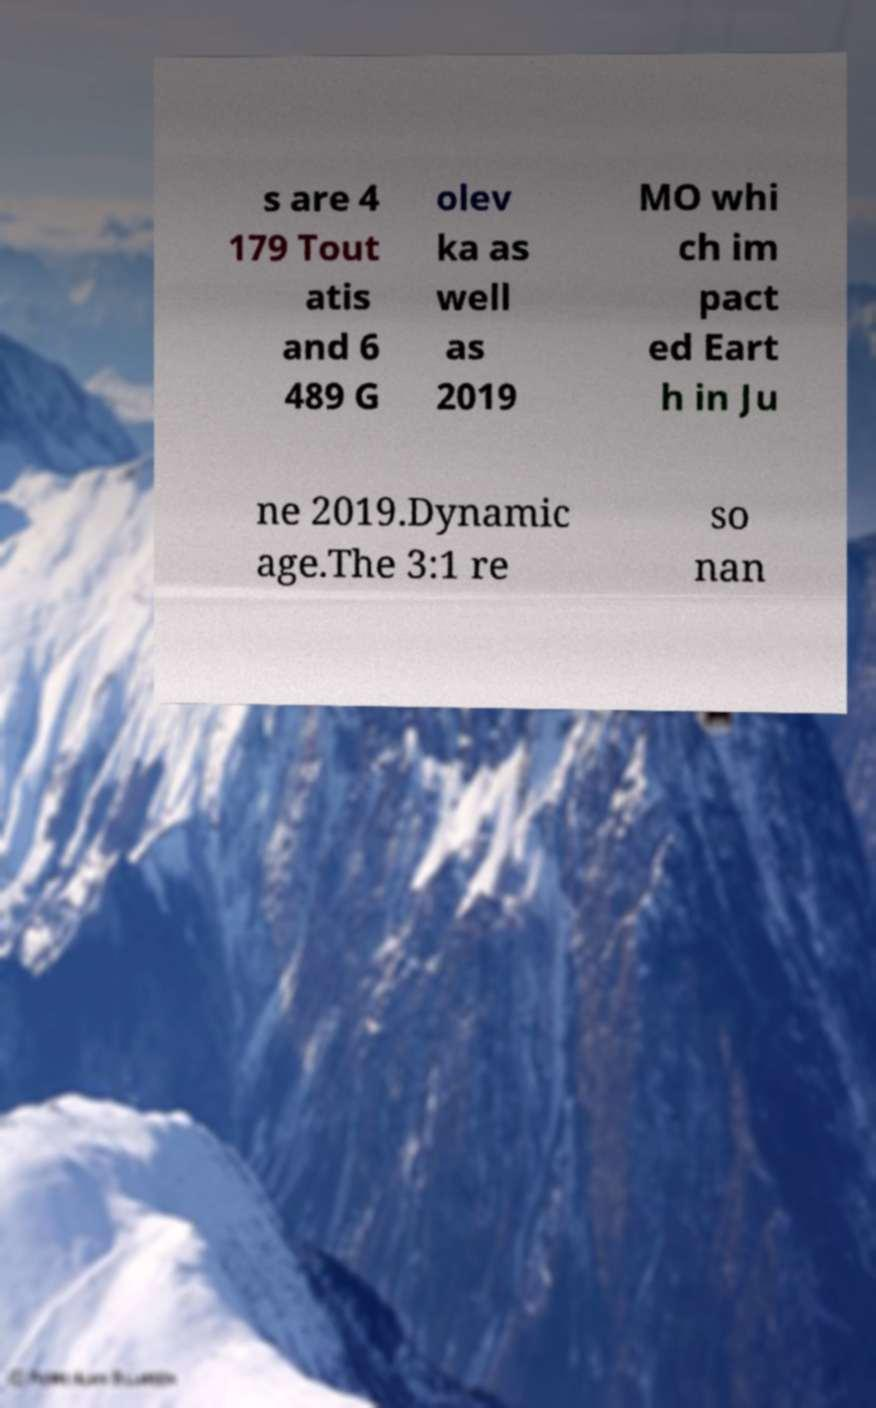What messages or text are displayed in this image? I need them in a readable, typed format. s are 4 179 Tout atis and 6 489 G olev ka as well as 2019 MO whi ch im pact ed Eart h in Ju ne 2019.Dynamic age.The 3:1 re so nan 